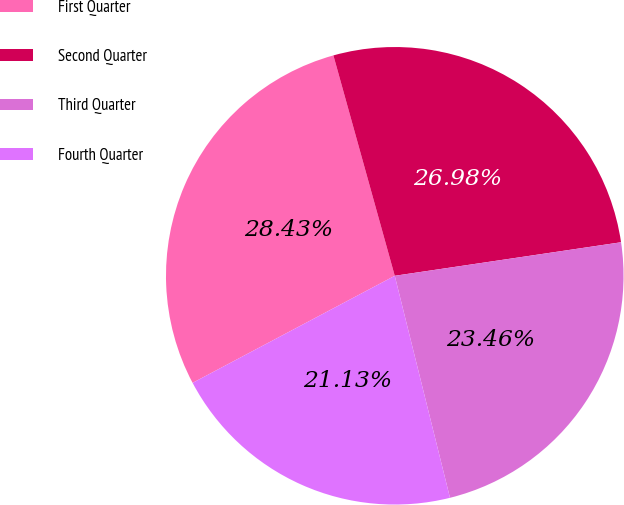Convert chart. <chart><loc_0><loc_0><loc_500><loc_500><pie_chart><fcel>First Quarter<fcel>Second Quarter<fcel>Third Quarter<fcel>Fourth Quarter<nl><fcel>28.43%<fcel>26.98%<fcel>23.46%<fcel>21.13%<nl></chart> 